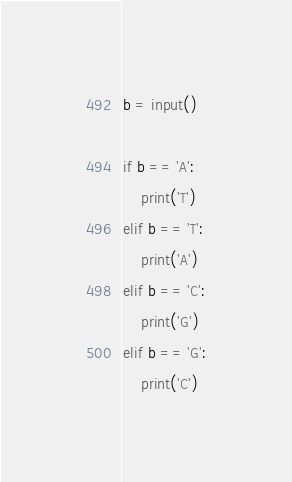<code> <loc_0><loc_0><loc_500><loc_500><_Python_>b = input()

if b == 'A':
    print('T')
elif b == 'T':
    print('A')
elif b == 'C':
    print('G')
elif b == 'G':
    print('C')</code> 